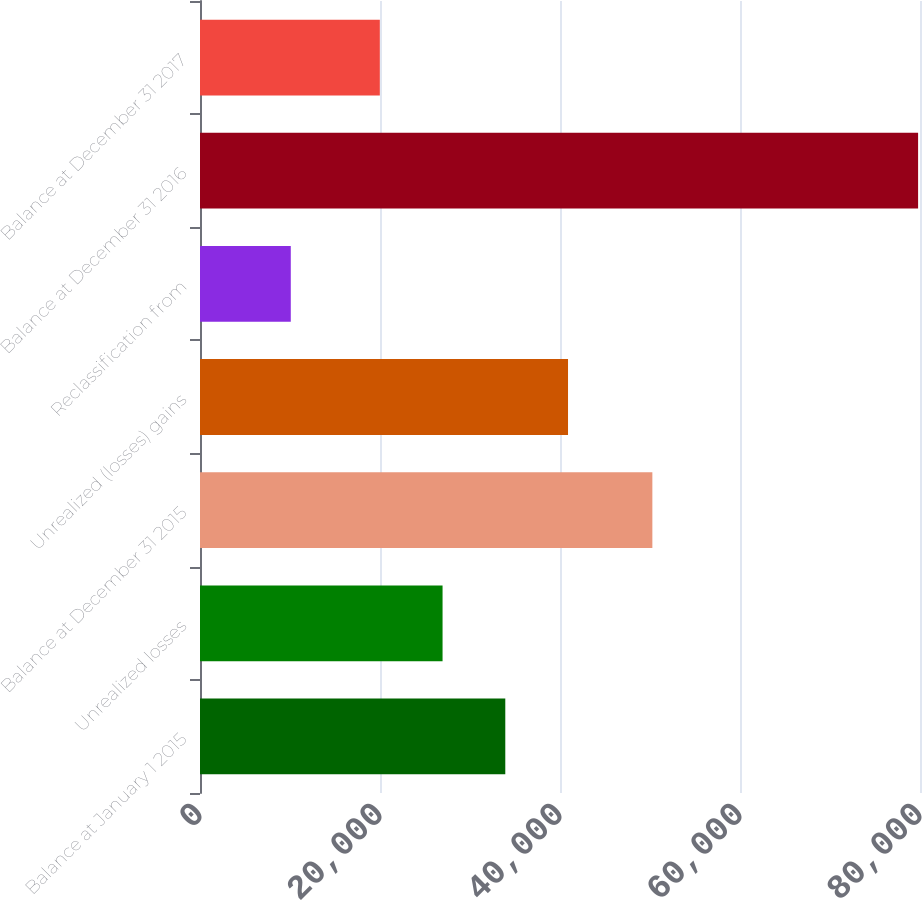<chart> <loc_0><loc_0><loc_500><loc_500><bar_chart><fcel>Balance at January 1 2015<fcel>Unrealized losses<fcel>Balance at December 31 2015<fcel>Unrealized (losses) gains<fcel>Reclassification from<fcel>Balance at December 31 2016<fcel>Balance at December 31 2017<nl><fcel>33921.4<fcel>26951.2<fcel>50262<fcel>40891.6<fcel>10087<fcel>79789<fcel>19981<nl></chart> 